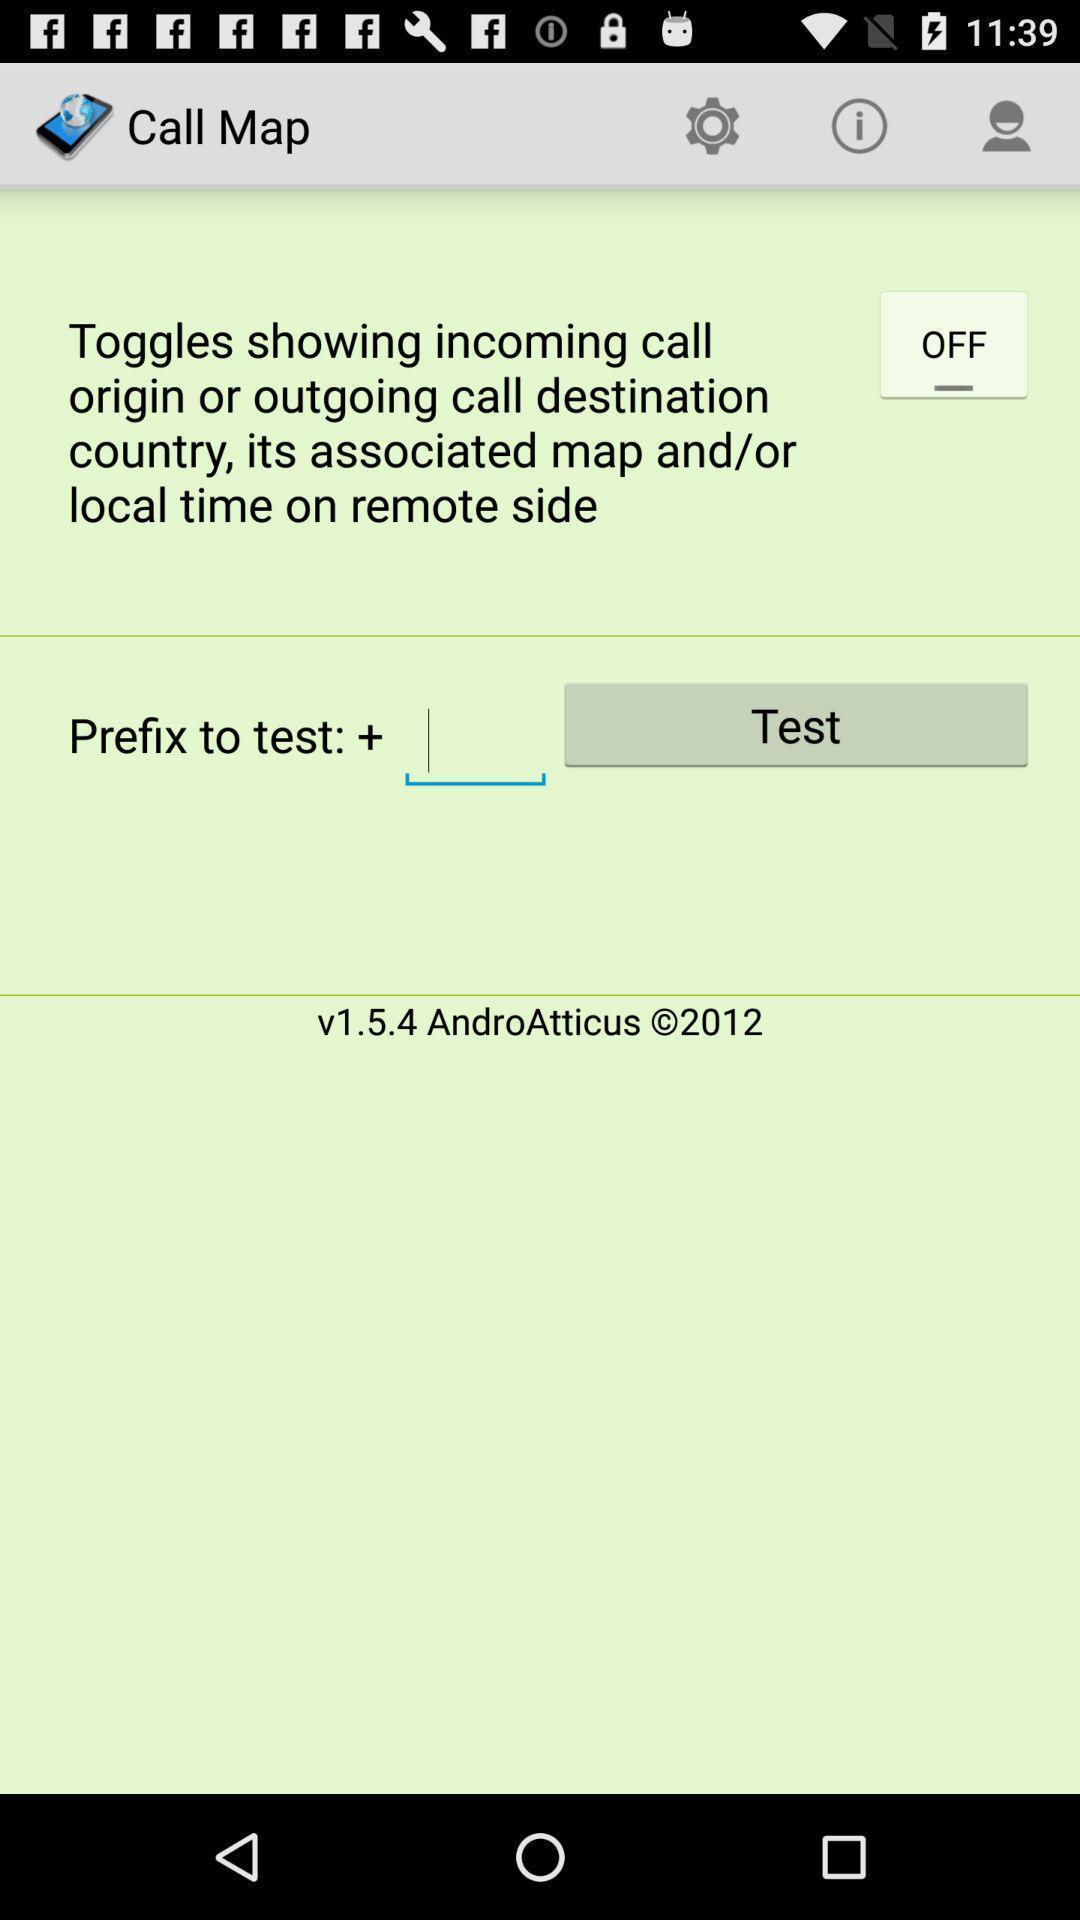Give me a narrative description of this picture. Page showing settings and icons in map app. 